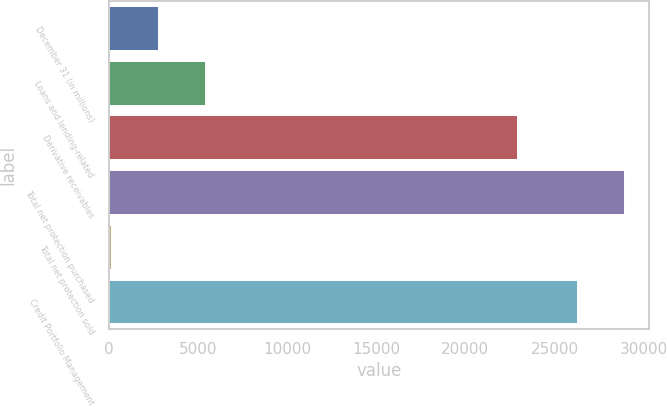<chart> <loc_0><loc_0><loc_500><loc_500><bar_chart><fcel>December 31 (in millions)<fcel>Loans and lending-related<fcel>Derivative receivables<fcel>Total net protection purchased<fcel>Total net protection sold<fcel>Credit Portfolio Management<nl><fcel>2755<fcel>5379<fcel>22883<fcel>28864<fcel>131<fcel>26240<nl></chart> 